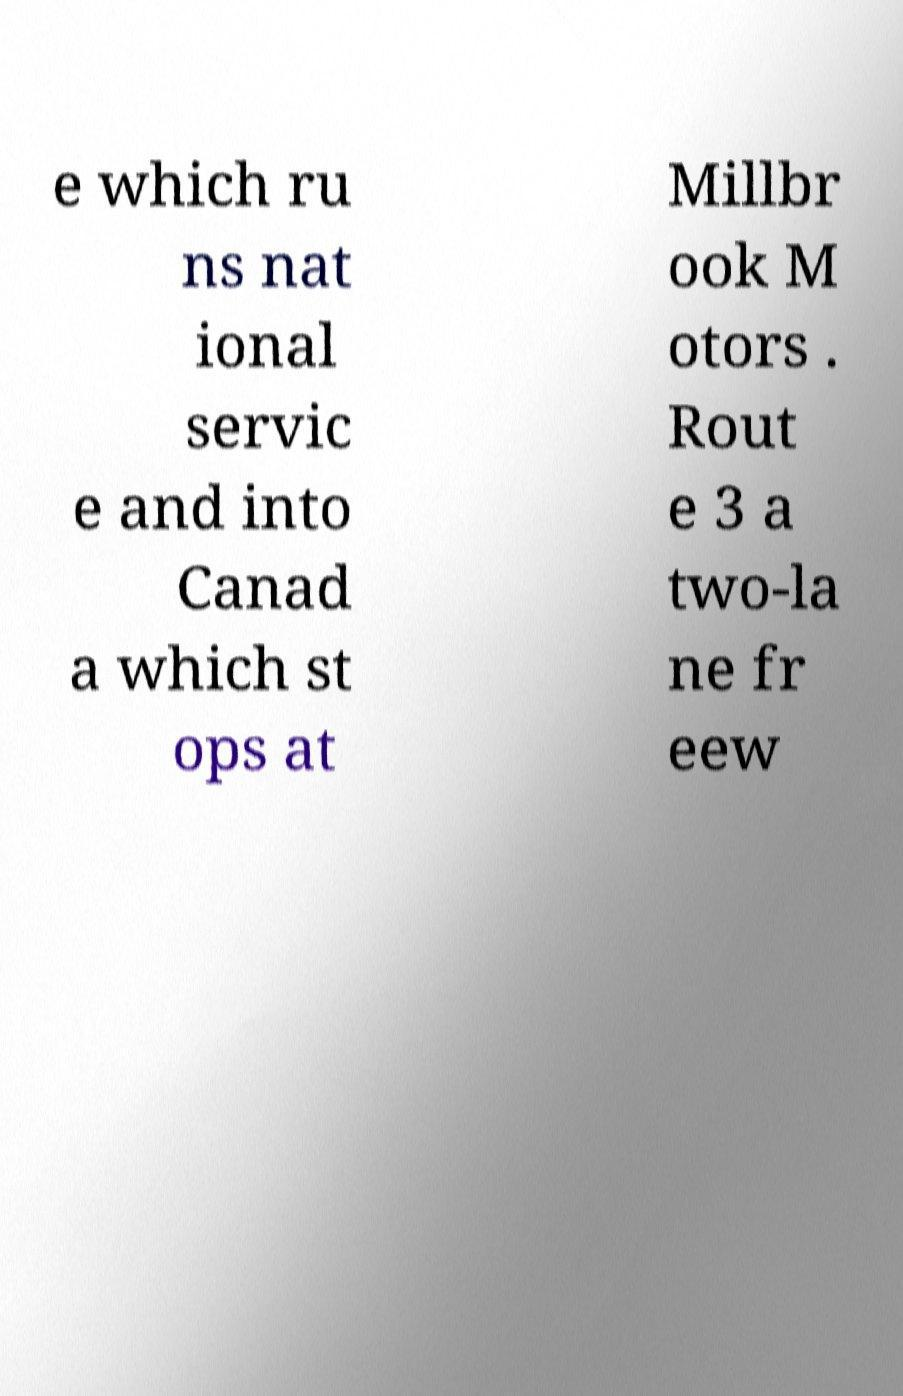Please identify and transcribe the text found in this image. e which ru ns nat ional servic e and into Canad a which st ops at Millbr ook M otors . Rout e 3 a two-la ne fr eew 